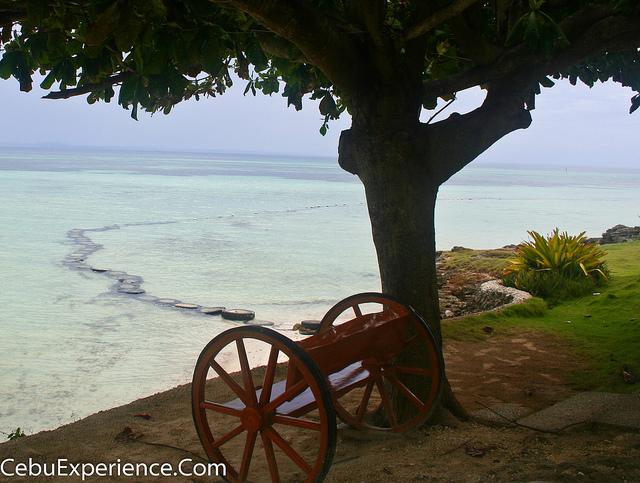What's the website?
Give a very brief answer. Cebu experiencecom. What is the object with the wheels used for?
Give a very brief answer. Sitting. Is this photo indoors?
Answer briefly. No. 